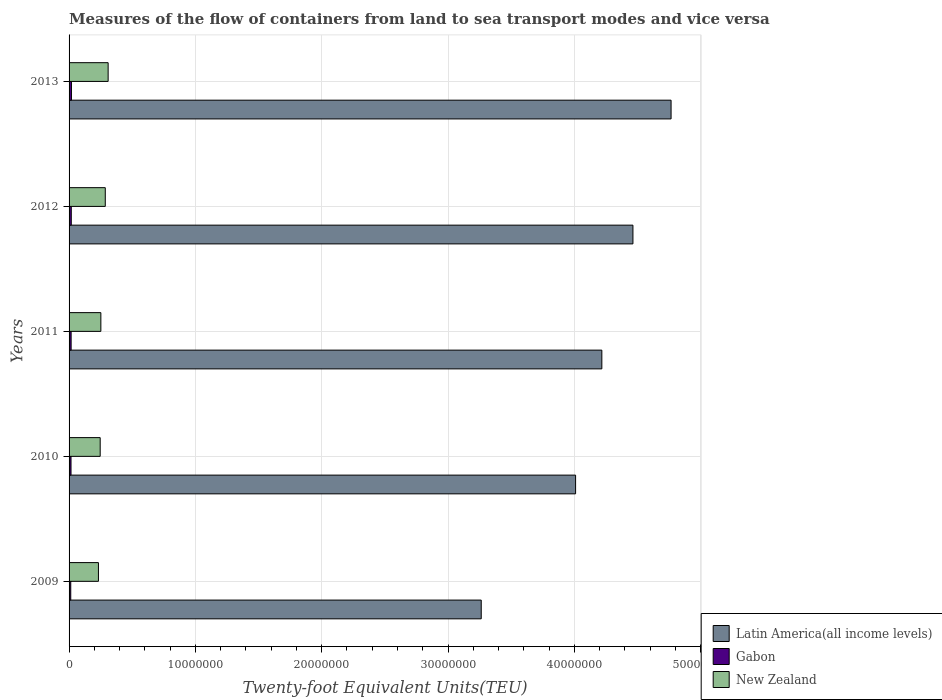How many groups of bars are there?
Ensure brevity in your answer.  5. Are the number of bars on each tick of the Y-axis equal?
Your response must be concise. Yes. What is the label of the 2nd group of bars from the top?
Give a very brief answer. 2012. What is the container port traffic in Latin America(all income levels) in 2010?
Your response must be concise. 4.01e+07. Across all years, what is the maximum container port traffic in Gabon?
Make the answer very short. 1.88e+05. Across all years, what is the minimum container port traffic in Latin America(all income levels)?
Offer a very short reply. 3.26e+07. What is the total container port traffic in New Zealand in the graph?
Provide a short and direct response. 1.33e+07. What is the difference between the container port traffic in Latin America(all income levels) in 2010 and that in 2011?
Ensure brevity in your answer.  -2.08e+06. What is the difference between the container port traffic in Gabon in 2009 and the container port traffic in New Zealand in 2012?
Offer a terse response. -2.73e+06. What is the average container port traffic in Latin America(all income levels) per year?
Offer a very short reply. 4.14e+07. In the year 2011, what is the difference between the container port traffic in Latin America(all income levels) and container port traffic in New Zealand?
Offer a terse response. 3.97e+07. In how many years, is the container port traffic in Latin America(all income levels) greater than 2000000 TEU?
Keep it short and to the point. 5. What is the ratio of the container port traffic in Latin America(all income levels) in 2009 to that in 2011?
Ensure brevity in your answer.  0.77. What is the difference between the highest and the second highest container port traffic in New Zealand?
Make the answer very short. 2.26e+05. What is the difference between the highest and the lowest container port traffic in New Zealand?
Ensure brevity in your answer.  7.68e+05. In how many years, is the container port traffic in Gabon greater than the average container port traffic in Gabon taken over all years?
Ensure brevity in your answer.  3. Is the sum of the container port traffic in Latin America(all income levels) in 2011 and 2012 greater than the maximum container port traffic in New Zealand across all years?
Your answer should be compact. Yes. What does the 3rd bar from the top in 2012 represents?
Your answer should be compact. Latin America(all income levels). What does the 1st bar from the bottom in 2013 represents?
Make the answer very short. Latin America(all income levels). Is it the case that in every year, the sum of the container port traffic in New Zealand and container port traffic in Latin America(all income levels) is greater than the container port traffic in Gabon?
Your answer should be compact. Yes. How many years are there in the graph?
Offer a terse response. 5. What is the difference between two consecutive major ticks on the X-axis?
Your response must be concise. 1.00e+07. Where does the legend appear in the graph?
Ensure brevity in your answer.  Bottom right. How many legend labels are there?
Keep it short and to the point. 3. How are the legend labels stacked?
Make the answer very short. Vertical. What is the title of the graph?
Provide a succinct answer. Measures of the flow of containers from land to sea transport modes and vice versa. What is the label or title of the X-axis?
Give a very brief answer. Twenty-foot Equivalent Units(TEU). What is the label or title of the Y-axis?
Your answer should be very brief. Years. What is the Twenty-foot Equivalent Units(TEU) in Latin America(all income levels) in 2009?
Ensure brevity in your answer.  3.26e+07. What is the Twenty-foot Equivalent Units(TEU) of Gabon in 2009?
Give a very brief answer. 1.32e+05. What is the Twenty-foot Equivalent Units(TEU) in New Zealand in 2009?
Provide a short and direct response. 2.32e+06. What is the Twenty-foot Equivalent Units(TEU) of Latin America(all income levels) in 2010?
Provide a succinct answer. 4.01e+07. What is the Twenty-foot Equivalent Units(TEU) of Gabon in 2010?
Give a very brief answer. 1.54e+05. What is the Twenty-foot Equivalent Units(TEU) in New Zealand in 2010?
Your response must be concise. 2.46e+06. What is the Twenty-foot Equivalent Units(TEU) in Latin America(all income levels) in 2011?
Your answer should be compact. 4.22e+07. What is the Twenty-foot Equivalent Units(TEU) of Gabon in 2011?
Provide a short and direct response. 1.62e+05. What is the Twenty-foot Equivalent Units(TEU) in New Zealand in 2011?
Your response must be concise. 2.52e+06. What is the Twenty-foot Equivalent Units(TEU) in Latin America(all income levels) in 2012?
Provide a short and direct response. 4.46e+07. What is the Twenty-foot Equivalent Units(TEU) in Gabon in 2012?
Ensure brevity in your answer.  1.75e+05. What is the Twenty-foot Equivalent Units(TEU) of New Zealand in 2012?
Your response must be concise. 2.87e+06. What is the Twenty-foot Equivalent Units(TEU) in Latin America(all income levels) in 2013?
Offer a very short reply. 4.77e+07. What is the Twenty-foot Equivalent Units(TEU) of Gabon in 2013?
Offer a terse response. 1.88e+05. What is the Twenty-foot Equivalent Units(TEU) in New Zealand in 2013?
Ensure brevity in your answer.  3.09e+06. Across all years, what is the maximum Twenty-foot Equivalent Units(TEU) in Latin America(all income levels)?
Offer a very short reply. 4.77e+07. Across all years, what is the maximum Twenty-foot Equivalent Units(TEU) of Gabon?
Your answer should be compact. 1.88e+05. Across all years, what is the maximum Twenty-foot Equivalent Units(TEU) of New Zealand?
Your response must be concise. 3.09e+06. Across all years, what is the minimum Twenty-foot Equivalent Units(TEU) of Latin America(all income levels)?
Provide a short and direct response. 3.26e+07. Across all years, what is the minimum Twenty-foot Equivalent Units(TEU) of Gabon?
Make the answer very short. 1.32e+05. Across all years, what is the minimum Twenty-foot Equivalent Units(TEU) in New Zealand?
Offer a terse response. 2.32e+06. What is the total Twenty-foot Equivalent Units(TEU) of Latin America(all income levels) in the graph?
Your answer should be compact. 2.07e+08. What is the total Twenty-foot Equivalent Units(TEU) of Gabon in the graph?
Give a very brief answer. 8.11e+05. What is the total Twenty-foot Equivalent Units(TEU) in New Zealand in the graph?
Provide a succinct answer. 1.33e+07. What is the difference between the Twenty-foot Equivalent Units(TEU) of Latin America(all income levels) in 2009 and that in 2010?
Your response must be concise. -7.47e+06. What is the difference between the Twenty-foot Equivalent Units(TEU) of Gabon in 2009 and that in 2010?
Provide a short and direct response. -2.13e+04. What is the difference between the Twenty-foot Equivalent Units(TEU) in New Zealand in 2009 and that in 2010?
Provide a short and direct response. -1.38e+05. What is the difference between the Twenty-foot Equivalent Units(TEU) of Latin America(all income levels) in 2009 and that in 2011?
Ensure brevity in your answer.  -9.55e+06. What is the difference between the Twenty-foot Equivalent Units(TEU) of Gabon in 2009 and that in 2011?
Give a very brief answer. -3.01e+04. What is the difference between the Twenty-foot Equivalent Units(TEU) in New Zealand in 2009 and that in 2011?
Make the answer very short. -1.92e+05. What is the difference between the Twenty-foot Equivalent Units(TEU) of Latin America(all income levels) in 2009 and that in 2012?
Keep it short and to the point. -1.20e+07. What is the difference between the Twenty-foot Equivalent Units(TEU) in Gabon in 2009 and that in 2012?
Your answer should be very brief. -4.22e+04. What is the difference between the Twenty-foot Equivalent Units(TEU) of New Zealand in 2009 and that in 2012?
Provide a succinct answer. -5.42e+05. What is the difference between the Twenty-foot Equivalent Units(TEU) of Latin America(all income levels) in 2009 and that in 2013?
Make the answer very short. -1.50e+07. What is the difference between the Twenty-foot Equivalent Units(TEU) of Gabon in 2009 and that in 2013?
Make the answer very short. -5.60e+04. What is the difference between the Twenty-foot Equivalent Units(TEU) of New Zealand in 2009 and that in 2013?
Give a very brief answer. -7.68e+05. What is the difference between the Twenty-foot Equivalent Units(TEU) of Latin America(all income levels) in 2010 and that in 2011?
Keep it short and to the point. -2.08e+06. What is the difference between the Twenty-foot Equivalent Units(TEU) of Gabon in 2010 and that in 2011?
Provide a succinct answer. -8758.45. What is the difference between the Twenty-foot Equivalent Units(TEU) of New Zealand in 2010 and that in 2011?
Your response must be concise. -5.34e+04. What is the difference between the Twenty-foot Equivalent Units(TEU) in Latin America(all income levels) in 2010 and that in 2012?
Make the answer very short. -4.54e+06. What is the difference between the Twenty-foot Equivalent Units(TEU) in Gabon in 2010 and that in 2012?
Offer a very short reply. -2.09e+04. What is the difference between the Twenty-foot Equivalent Units(TEU) in New Zealand in 2010 and that in 2012?
Provide a succinct answer. -4.03e+05. What is the difference between the Twenty-foot Equivalent Units(TEU) in Latin America(all income levels) in 2010 and that in 2013?
Your answer should be very brief. -7.56e+06. What is the difference between the Twenty-foot Equivalent Units(TEU) in Gabon in 2010 and that in 2013?
Offer a terse response. -3.47e+04. What is the difference between the Twenty-foot Equivalent Units(TEU) in New Zealand in 2010 and that in 2013?
Your response must be concise. -6.30e+05. What is the difference between the Twenty-foot Equivalent Units(TEU) in Latin America(all income levels) in 2011 and that in 2012?
Your answer should be compact. -2.46e+06. What is the difference between the Twenty-foot Equivalent Units(TEU) of Gabon in 2011 and that in 2012?
Make the answer very short. -1.22e+04. What is the difference between the Twenty-foot Equivalent Units(TEU) of New Zealand in 2011 and that in 2012?
Your response must be concise. -3.50e+05. What is the difference between the Twenty-foot Equivalent Units(TEU) in Latin America(all income levels) in 2011 and that in 2013?
Offer a terse response. -5.48e+06. What is the difference between the Twenty-foot Equivalent Units(TEU) of Gabon in 2011 and that in 2013?
Provide a succinct answer. -2.60e+04. What is the difference between the Twenty-foot Equivalent Units(TEU) of New Zealand in 2011 and that in 2013?
Your response must be concise. -5.76e+05. What is the difference between the Twenty-foot Equivalent Units(TEU) in Latin America(all income levels) in 2012 and that in 2013?
Keep it short and to the point. -3.02e+06. What is the difference between the Twenty-foot Equivalent Units(TEU) of Gabon in 2012 and that in 2013?
Offer a very short reply. -1.38e+04. What is the difference between the Twenty-foot Equivalent Units(TEU) of New Zealand in 2012 and that in 2013?
Ensure brevity in your answer.  -2.26e+05. What is the difference between the Twenty-foot Equivalent Units(TEU) in Latin America(all income levels) in 2009 and the Twenty-foot Equivalent Units(TEU) in Gabon in 2010?
Give a very brief answer. 3.25e+07. What is the difference between the Twenty-foot Equivalent Units(TEU) of Latin America(all income levels) in 2009 and the Twenty-foot Equivalent Units(TEU) of New Zealand in 2010?
Ensure brevity in your answer.  3.02e+07. What is the difference between the Twenty-foot Equivalent Units(TEU) in Gabon in 2009 and the Twenty-foot Equivalent Units(TEU) in New Zealand in 2010?
Your response must be concise. -2.33e+06. What is the difference between the Twenty-foot Equivalent Units(TEU) of Latin America(all income levels) in 2009 and the Twenty-foot Equivalent Units(TEU) of Gabon in 2011?
Ensure brevity in your answer.  3.25e+07. What is the difference between the Twenty-foot Equivalent Units(TEU) of Latin America(all income levels) in 2009 and the Twenty-foot Equivalent Units(TEU) of New Zealand in 2011?
Your answer should be compact. 3.01e+07. What is the difference between the Twenty-foot Equivalent Units(TEU) of Gabon in 2009 and the Twenty-foot Equivalent Units(TEU) of New Zealand in 2011?
Provide a succinct answer. -2.38e+06. What is the difference between the Twenty-foot Equivalent Units(TEU) of Latin America(all income levels) in 2009 and the Twenty-foot Equivalent Units(TEU) of Gabon in 2012?
Offer a terse response. 3.25e+07. What is the difference between the Twenty-foot Equivalent Units(TEU) of Latin America(all income levels) in 2009 and the Twenty-foot Equivalent Units(TEU) of New Zealand in 2012?
Give a very brief answer. 2.98e+07. What is the difference between the Twenty-foot Equivalent Units(TEU) in Gabon in 2009 and the Twenty-foot Equivalent Units(TEU) in New Zealand in 2012?
Your response must be concise. -2.73e+06. What is the difference between the Twenty-foot Equivalent Units(TEU) of Latin America(all income levels) in 2009 and the Twenty-foot Equivalent Units(TEU) of Gabon in 2013?
Make the answer very short. 3.24e+07. What is the difference between the Twenty-foot Equivalent Units(TEU) in Latin America(all income levels) in 2009 and the Twenty-foot Equivalent Units(TEU) in New Zealand in 2013?
Your answer should be compact. 2.95e+07. What is the difference between the Twenty-foot Equivalent Units(TEU) in Gabon in 2009 and the Twenty-foot Equivalent Units(TEU) in New Zealand in 2013?
Offer a very short reply. -2.96e+06. What is the difference between the Twenty-foot Equivalent Units(TEU) of Latin America(all income levels) in 2010 and the Twenty-foot Equivalent Units(TEU) of Gabon in 2011?
Your answer should be compact. 3.99e+07. What is the difference between the Twenty-foot Equivalent Units(TEU) of Latin America(all income levels) in 2010 and the Twenty-foot Equivalent Units(TEU) of New Zealand in 2011?
Keep it short and to the point. 3.76e+07. What is the difference between the Twenty-foot Equivalent Units(TEU) in Gabon in 2010 and the Twenty-foot Equivalent Units(TEU) in New Zealand in 2011?
Provide a succinct answer. -2.36e+06. What is the difference between the Twenty-foot Equivalent Units(TEU) of Latin America(all income levels) in 2010 and the Twenty-foot Equivalent Units(TEU) of Gabon in 2012?
Keep it short and to the point. 3.99e+07. What is the difference between the Twenty-foot Equivalent Units(TEU) in Latin America(all income levels) in 2010 and the Twenty-foot Equivalent Units(TEU) in New Zealand in 2012?
Keep it short and to the point. 3.72e+07. What is the difference between the Twenty-foot Equivalent Units(TEU) in Gabon in 2010 and the Twenty-foot Equivalent Units(TEU) in New Zealand in 2012?
Offer a terse response. -2.71e+06. What is the difference between the Twenty-foot Equivalent Units(TEU) of Latin America(all income levels) in 2010 and the Twenty-foot Equivalent Units(TEU) of Gabon in 2013?
Your answer should be very brief. 3.99e+07. What is the difference between the Twenty-foot Equivalent Units(TEU) of Latin America(all income levels) in 2010 and the Twenty-foot Equivalent Units(TEU) of New Zealand in 2013?
Offer a very short reply. 3.70e+07. What is the difference between the Twenty-foot Equivalent Units(TEU) of Gabon in 2010 and the Twenty-foot Equivalent Units(TEU) of New Zealand in 2013?
Keep it short and to the point. -2.94e+06. What is the difference between the Twenty-foot Equivalent Units(TEU) in Latin America(all income levels) in 2011 and the Twenty-foot Equivalent Units(TEU) in Gabon in 2012?
Your response must be concise. 4.20e+07. What is the difference between the Twenty-foot Equivalent Units(TEU) of Latin America(all income levels) in 2011 and the Twenty-foot Equivalent Units(TEU) of New Zealand in 2012?
Offer a very short reply. 3.93e+07. What is the difference between the Twenty-foot Equivalent Units(TEU) in Gabon in 2011 and the Twenty-foot Equivalent Units(TEU) in New Zealand in 2012?
Make the answer very short. -2.70e+06. What is the difference between the Twenty-foot Equivalent Units(TEU) in Latin America(all income levels) in 2011 and the Twenty-foot Equivalent Units(TEU) in Gabon in 2013?
Provide a succinct answer. 4.20e+07. What is the difference between the Twenty-foot Equivalent Units(TEU) of Latin America(all income levels) in 2011 and the Twenty-foot Equivalent Units(TEU) of New Zealand in 2013?
Offer a terse response. 3.91e+07. What is the difference between the Twenty-foot Equivalent Units(TEU) of Gabon in 2011 and the Twenty-foot Equivalent Units(TEU) of New Zealand in 2013?
Provide a succinct answer. -2.93e+06. What is the difference between the Twenty-foot Equivalent Units(TEU) of Latin America(all income levels) in 2012 and the Twenty-foot Equivalent Units(TEU) of Gabon in 2013?
Offer a terse response. 4.45e+07. What is the difference between the Twenty-foot Equivalent Units(TEU) of Latin America(all income levels) in 2012 and the Twenty-foot Equivalent Units(TEU) of New Zealand in 2013?
Offer a terse response. 4.15e+07. What is the difference between the Twenty-foot Equivalent Units(TEU) of Gabon in 2012 and the Twenty-foot Equivalent Units(TEU) of New Zealand in 2013?
Offer a very short reply. -2.92e+06. What is the average Twenty-foot Equivalent Units(TEU) in Latin America(all income levels) per year?
Keep it short and to the point. 4.14e+07. What is the average Twenty-foot Equivalent Units(TEU) of Gabon per year?
Make the answer very short. 1.62e+05. What is the average Twenty-foot Equivalent Units(TEU) in New Zealand per year?
Provide a short and direct response. 2.65e+06. In the year 2009, what is the difference between the Twenty-foot Equivalent Units(TEU) in Latin America(all income levels) and Twenty-foot Equivalent Units(TEU) in Gabon?
Your answer should be very brief. 3.25e+07. In the year 2009, what is the difference between the Twenty-foot Equivalent Units(TEU) in Latin America(all income levels) and Twenty-foot Equivalent Units(TEU) in New Zealand?
Provide a short and direct response. 3.03e+07. In the year 2009, what is the difference between the Twenty-foot Equivalent Units(TEU) of Gabon and Twenty-foot Equivalent Units(TEU) of New Zealand?
Ensure brevity in your answer.  -2.19e+06. In the year 2010, what is the difference between the Twenty-foot Equivalent Units(TEU) of Latin America(all income levels) and Twenty-foot Equivalent Units(TEU) of Gabon?
Your answer should be compact. 3.99e+07. In the year 2010, what is the difference between the Twenty-foot Equivalent Units(TEU) of Latin America(all income levels) and Twenty-foot Equivalent Units(TEU) of New Zealand?
Your answer should be very brief. 3.76e+07. In the year 2010, what is the difference between the Twenty-foot Equivalent Units(TEU) in Gabon and Twenty-foot Equivalent Units(TEU) in New Zealand?
Keep it short and to the point. -2.31e+06. In the year 2011, what is the difference between the Twenty-foot Equivalent Units(TEU) of Latin America(all income levels) and Twenty-foot Equivalent Units(TEU) of Gabon?
Your response must be concise. 4.20e+07. In the year 2011, what is the difference between the Twenty-foot Equivalent Units(TEU) of Latin America(all income levels) and Twenty-foot Equivalent Units(TEU) of New Zealand?
Make the answer very short. 3.97e+07. In the year 2011, what is the difference between the Twenty-foot Equivalent Units(TEU) in Gabon and Twenty-foot Equivalent Units(TEU) in New Zealand?
Ensure brevity in your answer.  -2.35e+06. In the year 2012, what is the difference between the Twenty-foot Equivalent Units(TEU) of Latin America(all income levels) and Twenty-foot Equivalent Units(TEU) of Gabon?
Provide a short and direct response. 4.45e+07. In the year 2012, what is the difference between the Twenty-foot Equivalent Units(TEU) in Latin America(all income levels) and Twenty-foot Equivalent Units(TEU) in New Zealand?
Your answer should be compact. 4.18e+07. In the year 2012, what is the difference between the Twenty-foot Equivalent Units(TEU) in Gabon and Twenty-foot Equivalent Units(TEU) in New Zealand?
Offer a very short reply. -2.69e+06. In the year 2013, what is the difference between the Twenty-foot Equivalent Units(TEU) in Latin America(all income levels) and Twenty-foot Equivalent Units(TEU) in Gabon?
Give a very brief answer. 4.75e+07. In the year 2013, what is the difference between the Twenty-foot Equivalent Units(TEU) of Latin America(all income levels) and Twenty-foot Equivalent Units(TEU) of New Zealand?
Keep it short and to the point. 4.46e+07. In the year 2013, what is the difference between the Twenty-foot Equivalent Units(TEU) in Gabon and Twenty-foot Equivalent Units(TEU) in New Zealand?
Offer a terse response. -2.90e+06. What is the ratio of the Twenty-foot Equivalent Units(TEU) in Latin America(all income levels) in 2009 to that in 2010?
Offer a terse response. 0.81. What is the ratio of the Twenty-foot Equivalent Units(TEU) in Gabon in 2009 to that in 2010?
Offer a very short reply. 0.86. What is the ratio of the Twenty-foot Equivalent Units(TEU) of New Zealand in 2009 to that in 2010?
Offer a terse response. 0.94. What is the ratio of the Twenty-foot Equivalent Units(TEU) of Latin America(all income levels) in 2009 to that in 2011?
Your answer should be very brief. 0.77. What is the ratio of the Twenty-foot Equivalent Units(TEU) in Gabon in 2009 to that in 2011?
Your answer should be very brief. 0.81. What is the ratio of the Twenty-foot Equivalent Units(TEU) of New Zealand in 2009 to that in 2011?
Your answer should be very brief. 0.92. What is the ratio of the Twenty-foot Equivalent Units(TEU) in Latin America(all income levels) in 2009 to that in 2012?
Provide a short and direct response. 0.73. What is the ratio of the Twenty-foot Equivalent Units(TEU) of Gabon in 2009 to that in 2012?
Provide a short and direct response. 0.76. What is the ratio of the Twenty-foot Equivalent Units(TEU) of New Zealand in 2009 to that in 2012?
Your answer should be compact. 0.81. What is the ratio of the Twenty-foot Equivalent Units(TEU) in Latin America(all income levels) in 2009 to that in 2013?
Make the answer very short. 0.68. What is the ratio of the Twenty-foot Equivalent Units(TEU) of Gabon in 2009 to that in 2013?
Keep it short and to the point. 0.7. What is the ratio of the Twenty-foot Equivalent Units(TEU) of New Zealand in 2009 to that in 2013?
Provide a succinct answer. 0.75. What is the ratio of the Twenty-foot Equivalent Units(TEU) of Latin America(all income levels) in 2010 to that in 2011?
Provide a short and direct response. 0.95. What is the ratio of the Twenty-foot Equivalent Units(TEU) in Gabon in 2010 to that in 2011?
Ensure brevity in your answer.  0.95. What is the ratio of the Twenty-foot Equivalent Units(TEU) of New Zealand in 2010 to that in 2011?
Offer a very short reply. 0.98. What is the ratio of the Twenty-foot Equivalent Units(TEU) of Latin America(all income levels) in 2010 to that in 2012?
Offer a terse response. 0.9. What is the ratio of the Twenty-foot Equivalent Units(TEU) in Gabon in 2010 to that in 2012?
Your answer should be compact. 0.88. What is the ratio of the Twenty-foot Equivalent Units(TEU) in New Zealand in 2010 to that in 2012?
Your response must be concise. 0.86. What is the ratio of the Twenty-foot Equivalent Units(TEU) of Latin America(all income levels) in 2010 to that in 2013?
Offer a terse response. 0.84. What is the ratio of the Twenty-foot Equivalent Units(TEU) in Gabon in 2010 to that in 2013?
Make the answer very short. 0.82. What is the ratio of the Twenty-foot Equivalent Units(TEU) in New Zealand in 2010 to that in 2013?
Ensure brevity in your answer.  0.8. What is the ratio of the Twenty-foot Equivalent Units(TEU) in Latin America(all income levels) in 2011 to that in 2012?
Your answer should be compact. 0.94. What is the ratio of the Twenty-foot Equivalent Units(TEU) of Gabon in 2011 to that in 2012?
Your answer should be very brief. 0.93. What is the ratio of the Twenty-foot Equivalent Units(TEU) in New Zealand in 2011 to that in 2012?
Ensure brevity in your answer.  0.88. What is the ratio of the Twenty-foot Equivalent Units(TEU) of Latin America(all income levels) in 2011 to that in 2013?
Make the answer very short. 0.89. What is the ratio of the Twenty-foot Equivalent Units(TEU) of Gabon in 2011 to that in 2013?
Your answer should be compact. 0.86. What is the ratio of the Twenty-foot Equivalent Units(TEU) in New Zealand in 2011 to that in 2013?
Provide a succinct answer. 0.81. What is the ratio of the Twenty-foot Equivalent Units(TEU) in Latin America(all income levels) in 2012 to that in 2013?
Your response must be concise. 0.94. What is the ratio of the Twenty-foot Equivalent Units(TEU) in Gabon in 2012 to that in 2013?
Make the answer very short. 0.93. What is the ratio of the Twenty-foot Equivalent Units(TEU) in New Zealand in 2012 to that in 2013?
Give a very brief answer. 0.93. What is the difference between the highest and the second highest Twenty-foot Equivalent Units(TEU) in Latin America(all income levels)?
Make the answer very short. 3.02e+06. What is the difference between the highest and the second highest Twenty-foot Equivalent Units(TEU) of Gabon?
Provide a short and direct response. 1.38e+04. What is the difference between the highest and the second highest Twenty-foot Equivalent Units(TEU) of New Zealand?
Make the answer very short. 2.26e+05. What is the difference between the highest and the lowest Twenty-foot Equivalent Units(TEU) in Latin America(all income levels)?
Offer a very short reply. 1.50e+07. What is the difference between the highest and the lowest Twenty-foot Equivalent Units(TEU) of Gabon?
Your answer should be compact. 5.60e+04. What is the difference between the highest and the lowest Twenty-foot Equivalent Units(TEU) of New Zealand?
Provide a succinct answer. 7.68e+05. 